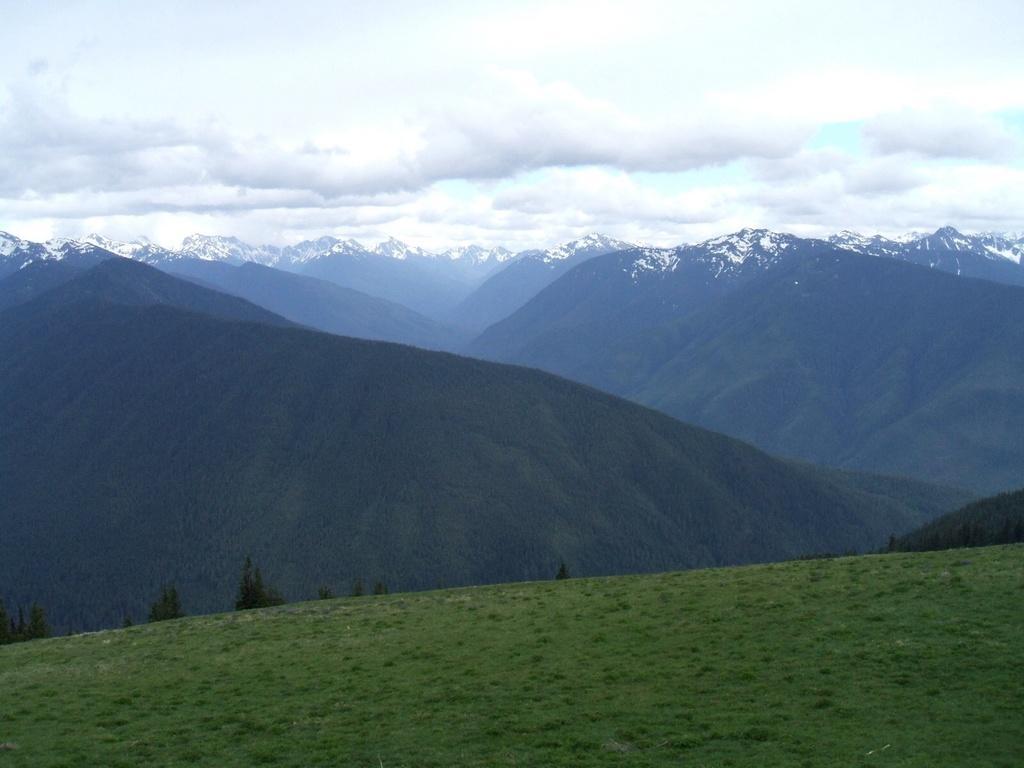Could you give a brief overview of what you see in this image? In the image we can see the grass, mountains and the cloudy sky. 